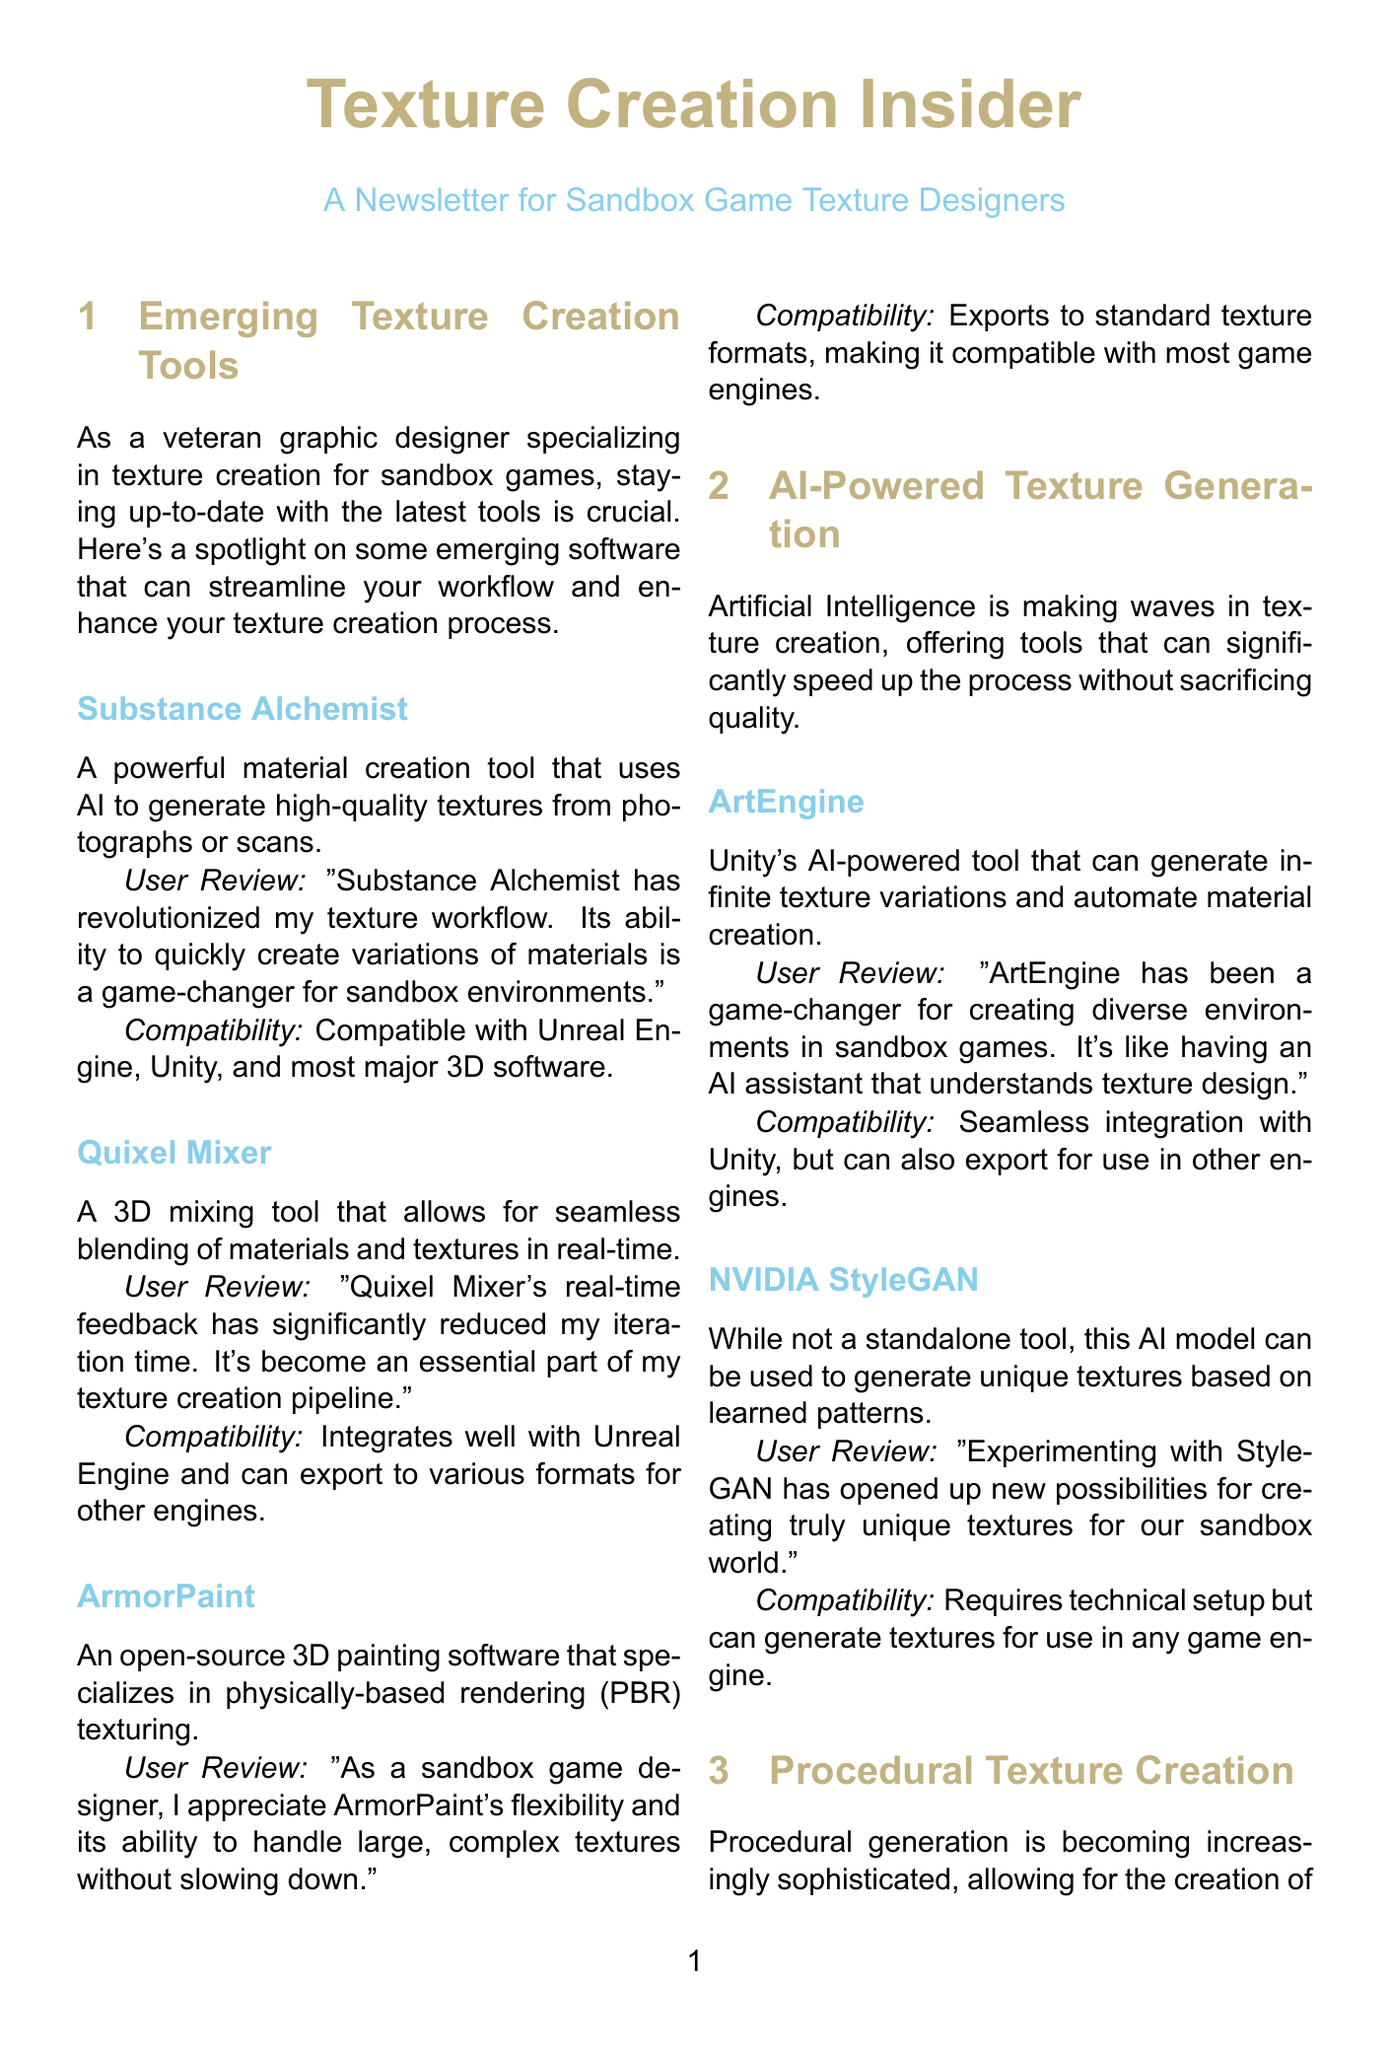What is the name of the tool that uses AI to generate high-quality textures from photographs? The document mentions Substance Alchemist as a tool that uses AI for generating textures from photographs.
Answer: Substance Alchemist Which tool is described as having improved cloud collaboration features? Substance 3D Painter is specifically highlighted for its improved cloud collaboration tools for texture creation.
Answer: Substance 3D Painter What type of software is ArmorPaint categorized as? The document classifies ArmorPaint as open-source 3D painting software that specializes in physically-based rendering texturing.
Answer: 3D painting software How does Quixel Mixer improve the texture creation process? Quixel Mixer is noted for providing real-time feedback, significantly reducing iteration time during texture creation.
Answer: Real-time feedback Which AI model is mentioned for generating unique textures based on learned patterns? The newsletter discusses NVIDIA StyleGAN as a model used for generating unique textures based on learned patterns.
Answer: NVIDIA StyleGAN What is the compatibility of Substance Designer with major game engines? The document states that Substance Designer exports to all major formats and integrates directly with most game engines, indicating its broad compatibility.
Answer: All major formats Which tool is designed for creating large-scale terrain textures? MapMaker is identified in the document as a specialized tool for creating large-scale terrain textures and blending maps.
Answer: MapMaker What is a notable feature of ArtEngine mentioned in the document? ArtEngine is highlighted for its ability to generate infinite texture variations and automate material creation.
Answer: Infinite texture variations What type of document is this? The content is structured as a newsletter, aimed at sand game texture designers and highlighting emerging tools.
Answer: Newsletter 